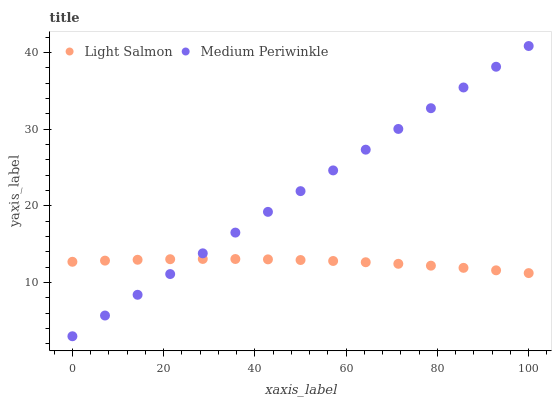Does Light Salmon have the minimum area under the curve?
Answer yes or no. Yes. Does Medium Periwinkle have the maximum area under the curve?
Answer yes or no. Yes. Does Medium Periwinkle have the minimum area under the curve?
Answer yes or no. No. Is Medium Periwinkle the smoothest?
Answer yes or no. Yes. Is Light Salmon the roughest?
Answer yes or no. Yes. Is Medium Periwinkle the roughest?
Answer yes or no. No. Does Medium Periwinkle have the lowest value?
Answer yes or no. Yes. Does Medium Periwinkle have the highest value?
Answer yes or no. Yes. Does Light Salmon intersect Medium Periwinkle?
Answer yes or no. Yes. Is Light Salmon less than Medium Periwinkle?
Answer yes or no. No. Is Light Salmon greater than Medium Periwinkle?
Answer yes or no. No. 